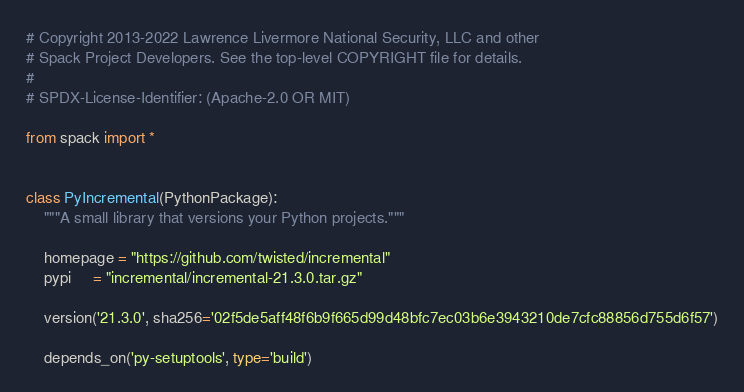<code> <loc_0><loc_0><loc_500><loc_500><_Python_># Copyright 2013-2022 Lawrence Livermore National Security, LLC and other
# Spack Project Developers. See the top-level COPYRIGHT file for details.
#
# SPDX-License-Identifier: (Apache-2.0 OR MIT)

from spack import *


class PyIncremental(PythonPackage):
    """A small library that versions your Python projects."""

    homepage = "https://github.com/twisted/incremental"
    pypi     = "incremental/incremental-21.3.0.tar.gz"

    version('21.3.0', sha256='02f5de5aff48f6b9f665d99d48bfc7ec03b6e3943210de7cfc88856d755d6f57')

    depends_on('py-setuptools', type='build')
</code> 